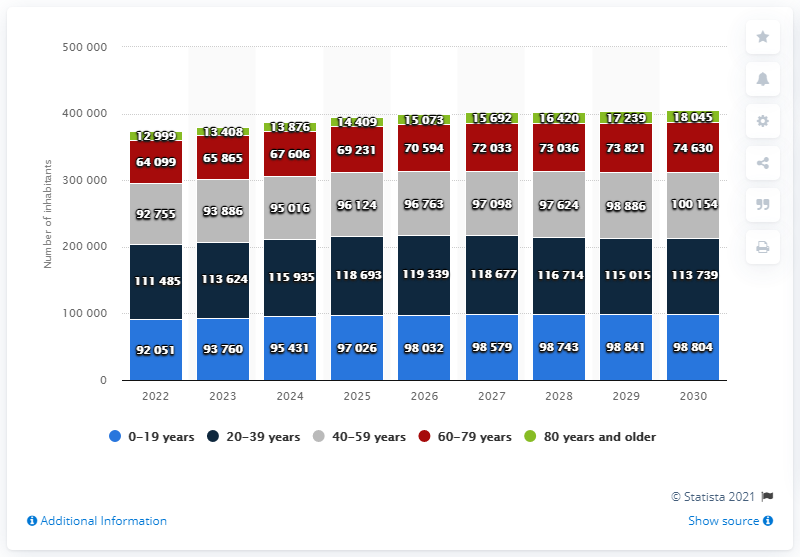Indicate a few pertinent items in this graphic. The term 'red' refers to the age group of 60-79 years. According to projections, the population in the 0-19 age group is expected to grow by approximately 7.33% from 2022 to 2030, with the municipality of 092051 increasing from 9,2051 to 9,8804 residents during this time period. 